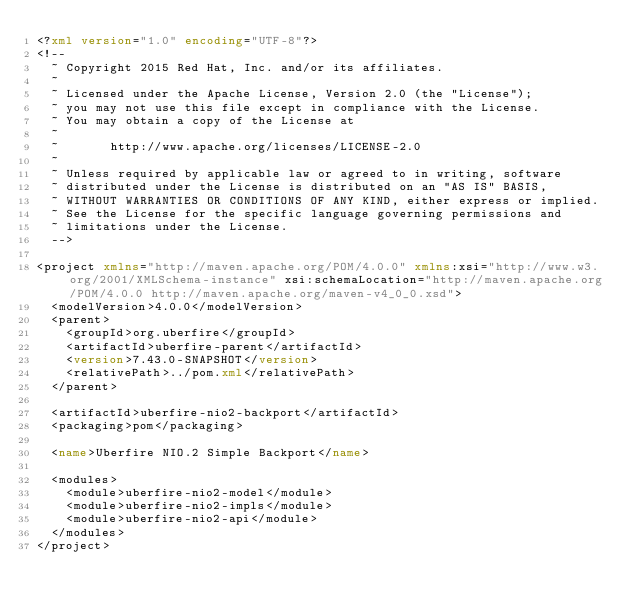Convert code to text. <code><loc_0><loc_0><loc_500><loc_500><_XML_><?xml version="1.0" encoding="UTF-8"?>
<!--
  ~ Copyright 2015 Red Hat, Inc. and/or its affiliates.
  ~
  ~ Licensed under the Apache License, Version 2.0 (the "License");
  ~ you may not use this file except in compliance with the License.
  ~ You may obtain a copy of the License at
  ~
  ~       http://www.apache.org/licenses/LICENSE-2.0
  ~
  ~ Unless required by applicable law or agreed to in writing, software
  ~ distributed under the License is distributed on an "AS IS" BASIS,
  ~ WITHOUT WARRANTIES OR CONDITIONS OF ANY KIND, either express or implied.
  ~ See the License for the specific language governing permissions and
  ~ limitations under the License.
  -->

<project xmlns="http://maven.apache.org/POM/4.0.0" xmlns:xsi="http://www.w3.org/2001/XMLSchema-instance" xsi:schemaLocation="http://maven.apache.org/POM/4.0.0 http://maven.apache.org/maven-v4_0_0.xsd">
  <modelVersion>4.0.0</modelVersion>
  <parent>
    <groupId>org.uberfire</groupId>
    <artifactId>uberfire-parent</artifactId>
    <version>7.43.0-SNAPSHOT</version>
    <relativePath>../pom.xml</relativePath>
  </parent>

  <artifactId>uberfire-nio2-backport</artifactId>
  <packaging>pom</packaging>

  <name>Uberfire NIO.2 Simple Backport</name>

  <modules>
    <module>uberfire-nio2-model</module>
    <module>uberfire-nio2-impls</module>
    <module>uberfire-nio2-api</module>
  </modules>
</project>
</code> 